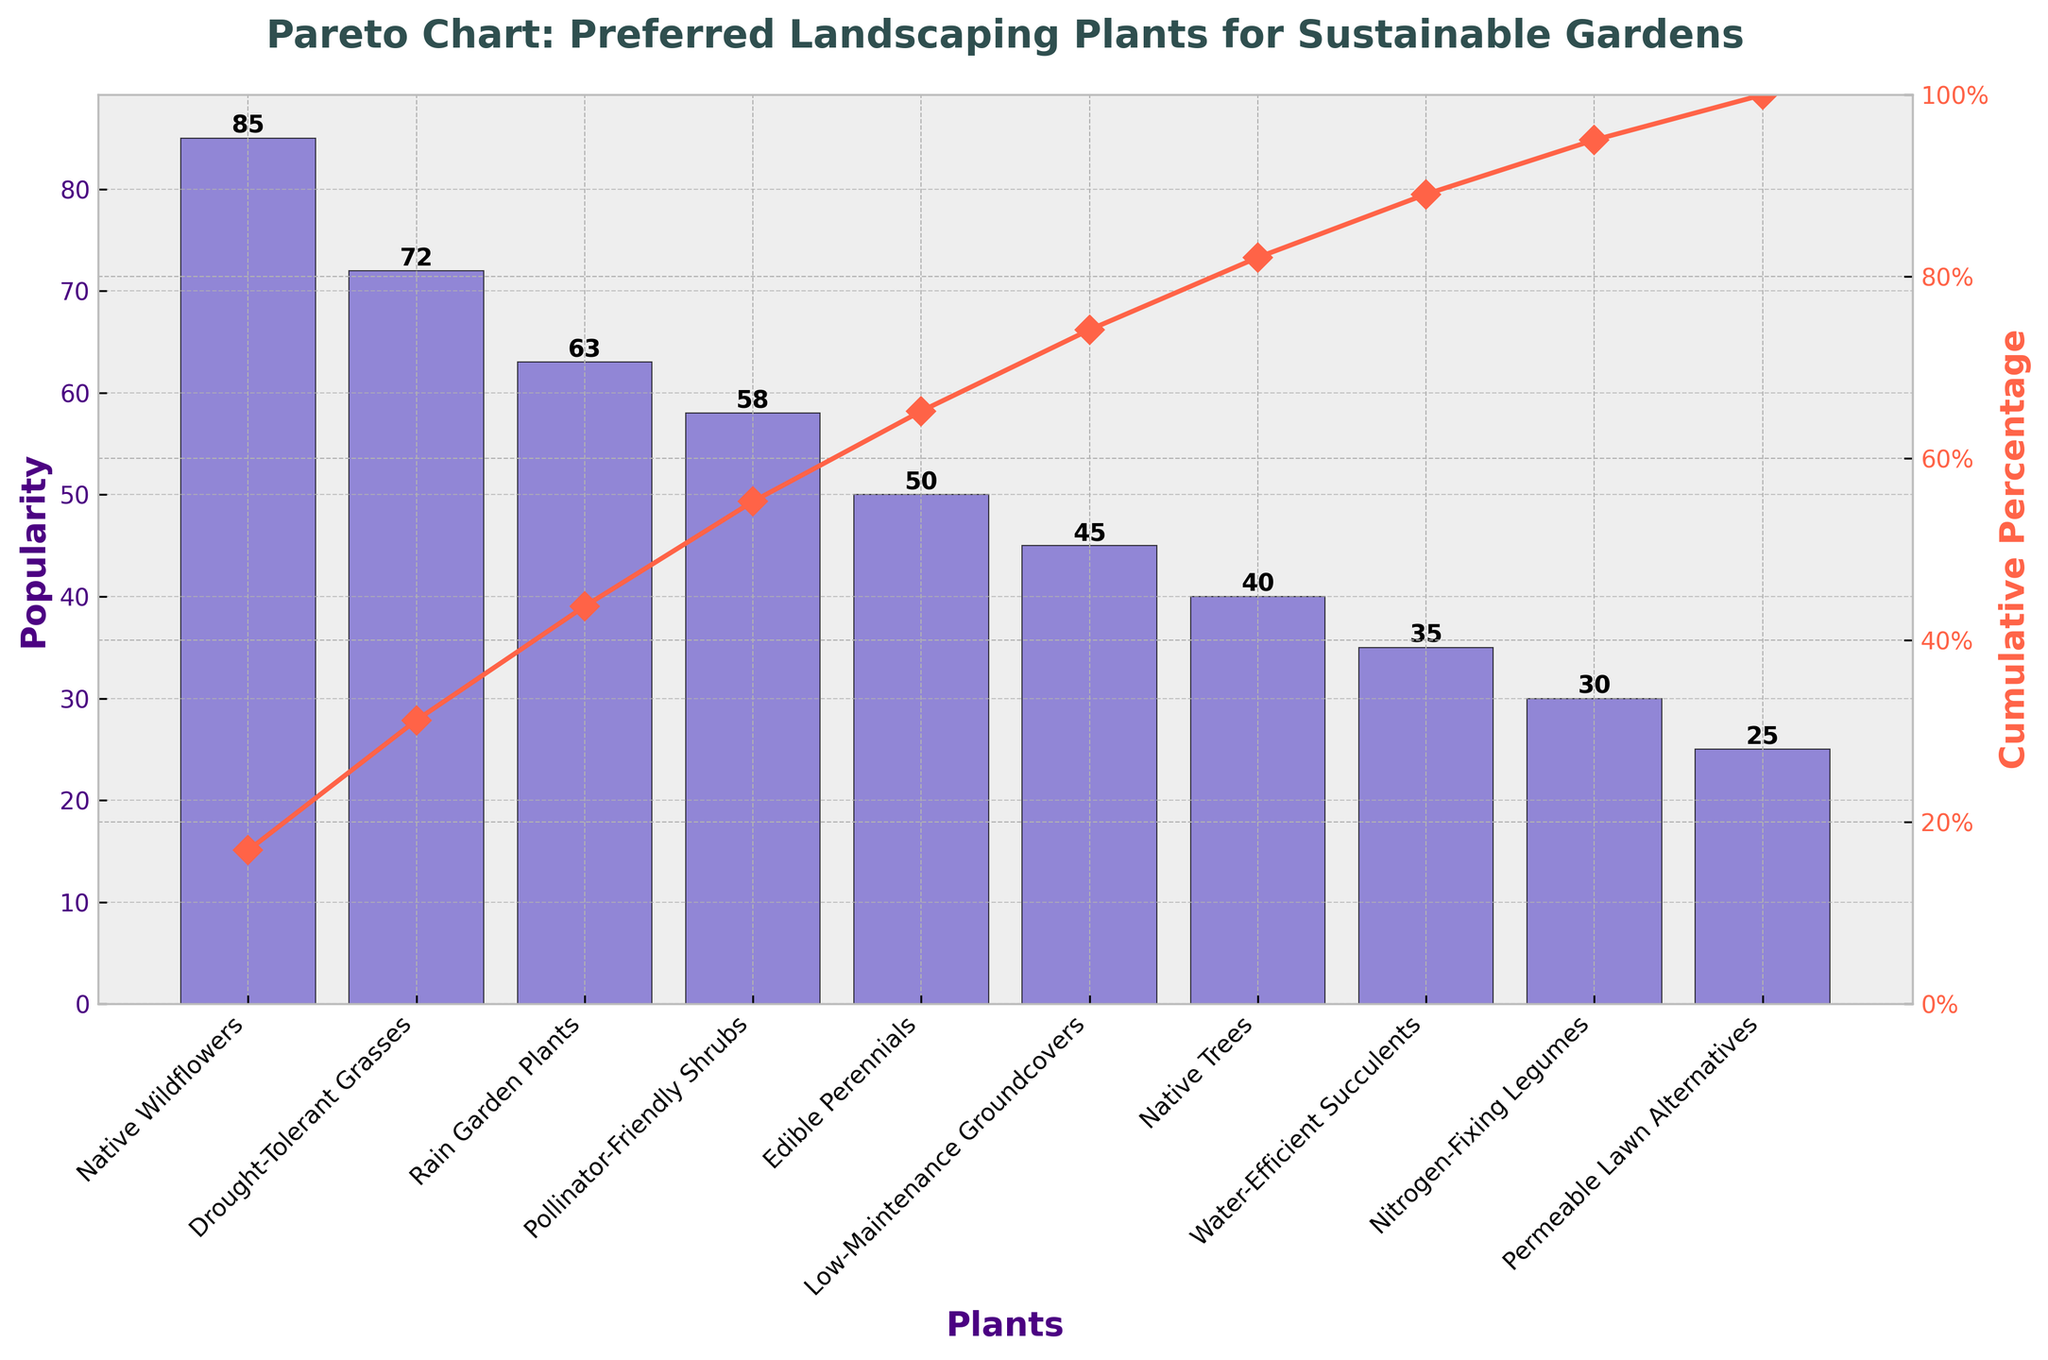What's the title of the figure? The title of the figure is located at the top and is commonly in a larger font and boldface. Here, it reads 'Pareto Chart: Preferred Landscaping Plants for Sustainable Gardens'.
Answer: Pareto Chart: Preferred Landscaping Plants for Sustainable Gardens What are the x-axis labels? The x-axis labels represent different plants. We can read these from the x-axis of the plot: Native Wildflowers, Drought-Tolerant Grasses, Rain Garden Plants, Pollinator-Friendly Shrubs, Edible Perennials, Low-Maintenance Groundcovers, Native Trees, Water-Efficient Succulents, Nitrogen-Fixing Legumes, Permeable Lawn Alternatives.
Answer: Native Wildflowers, Drought-Tolerant Grasses, Rain Garden Plants, Pollinator-Friendly Shrubs, Edible Perennials, Low-Maintenance Groundcovers, Native Trees, Water-Efficient Succulents, Nitrogen-Fixing Legumes, Permeable Lawn Alternatives What is the cumulative percentage for native wildflowers and drought-tolerant grasses combined? The cumulative percentage for Native Wildflowers is 20.35% and for Drought-Tolerant Grasses is 37.90%. The combined cumulative percentage is 20.35% + 37.90% = 58.25%.
Answer: 58.25% Which plant has the highest popularity? The plant with the highest popularity is identified by the tallest bar in the bar plot. Native Wildflowers have the tallest bar with a popularity of 85.
Answer: Native Wildflowers How does the line plot's curve behave compared to the bar heights? The line plot shows the cumulative percentage which increases as we move along the x-axis. Initially, it rises steeply, as the more popular plants contribute significantly to the cumulative percentage. As the less popular plants are added, the curve flattens.
Answer: It initially rises steeply then flattens What are the y-axis labels? The y-axis has two labels. The left y-axis is labeled 'Popularity', showing the numbers directly corresponding to the bar heights. The right y-axis is labeled 'Cumulative Percentage', showing the percentage values for the cumulative line plot.
Answer: Popularity, Cumulative Percentage Which plants constitute approximately the first 80% of popularity? Summing up the popularity percentages cumulatively: Native Wildflowers (20.35%), Drought-Tolerant Grasses (37.90%), Rain Garden Plants (52.56%), and Pollinator-Friendly Shrubs (66.39%). Adding Edible Perennials (78.57%) meets the criteria of 80% cumulative popularity.
Answer: Native Wildflowers, Drought-Tolerant Grasses, Rain Garden Plants, Pollinator-Friendly Shrubs, Edible Perennials How does the cumulative percentage change for the first and the last plant? The cumulative percentage change is significant initially: Native Wildflowers start at 0% and reach 20.35%. For the last plant, Permeable Lawn Alternatives, the cumulative percentage reaches 100%.
Answer: From 0% to 20.35% initially, and to 100% lastly Which plant ranks fourth in popularity? The fourth tallest bar represents the fourth most popular plant. Pollinator-Friendly Shrubs rank fourth in popularity with a value of 58.
Answer: Pollinator-Friendly Shrubs 